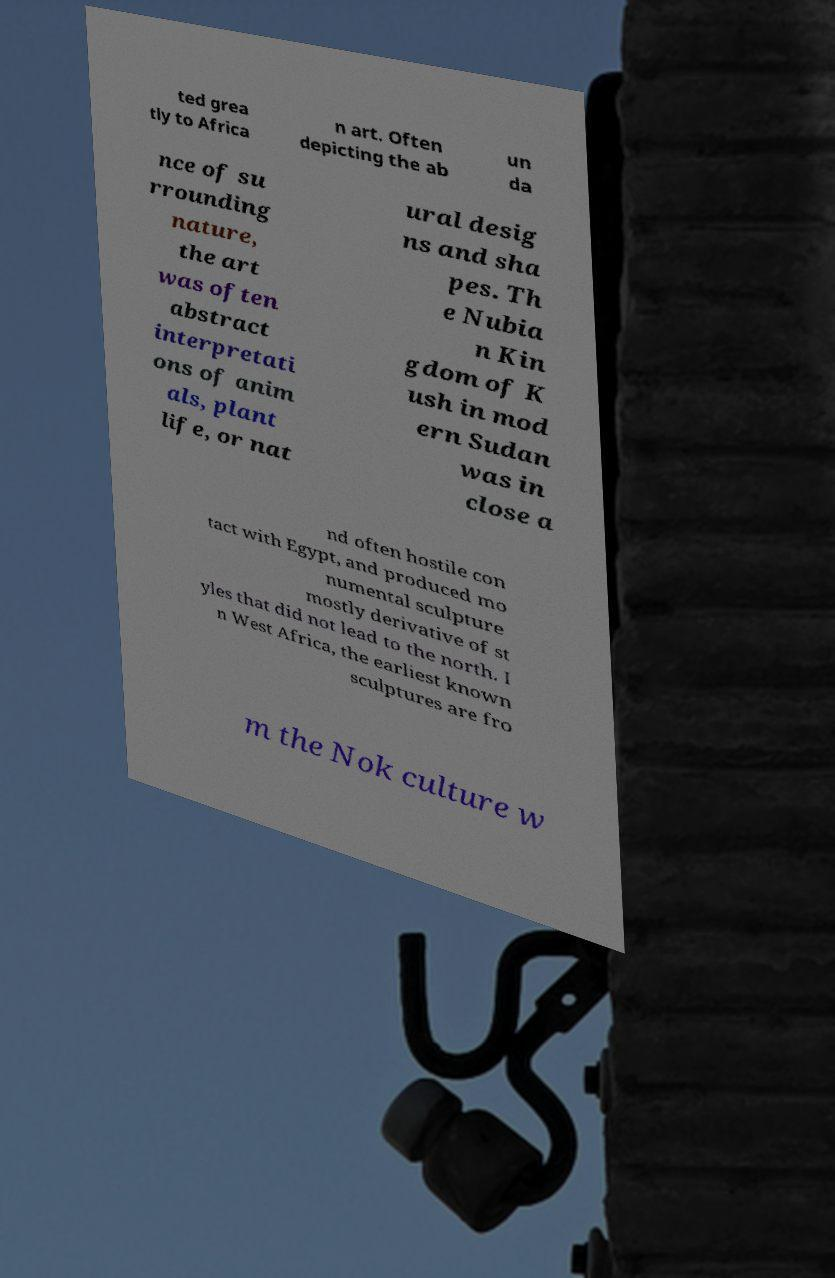Please identify and transcribe the text found in this image. ted grea tly to Africa n art. Often depicting the ab un da nce of su rrounding nature, the art was often abstract interpretati ons of anim als, plant life, or nat ural desig ns and sha pes. Th e Nubia n Kin gdom of K ush in mod ern Sudan was in close a nd often hostile con tact with Egypt, and produced mo numental sculpture mostly derivative of st yles that did not lead to the north. I n West Africa, the earliest known sculptures are fro m the Nok culture w 